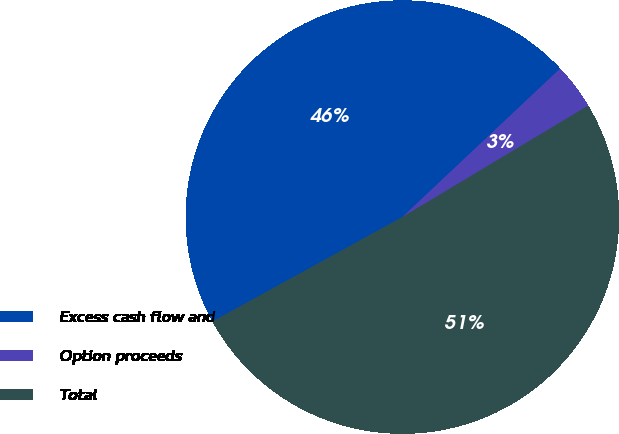<chart> <loc_0><loc_0><loc_500><loc_500><pie_chart><fcel>Excess cash flow and<fcel>Option proceeds<fcel>Total<nl><fcel>45.99%<fcel>3.42%<fcel>50.59%<nl></chart> 